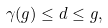Convert formula to latex. <formula><loc_0><loc_0><loc_500><loc_500>\gamma ( g ) \leq d \leq g ,</formula> 